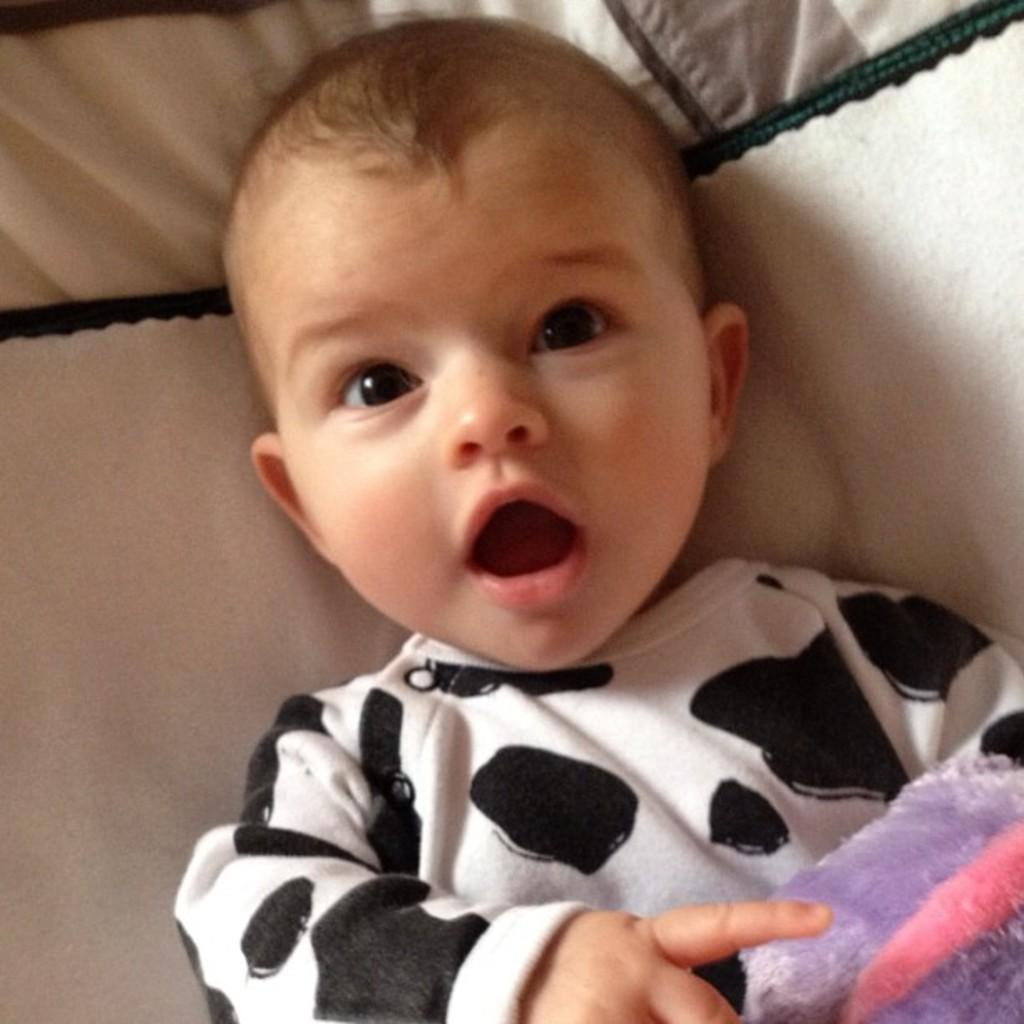What is the main subject of the image? There is a baby in the image. What is the baby lying on? The baby is lying on a cream color cloth. What is the baby wearing? The baby is wearing a black and white color dress. What type of industry can be seen in the background of the image? There is no industry visible in the image; it only features a baby lying on a cream color cloth and wearing a black and white dress. 